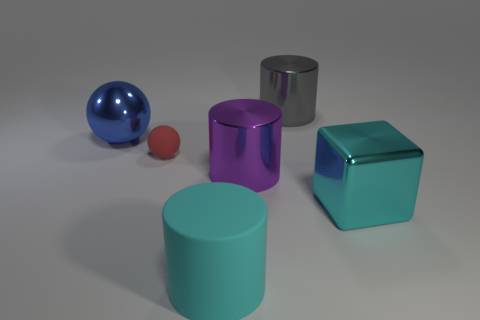What shapes can be observed in the image? The image showcases a variety of shapes including a silver cylinder, a purple cube, another cyan cylinder, a red sphere, and a blue sphere. 